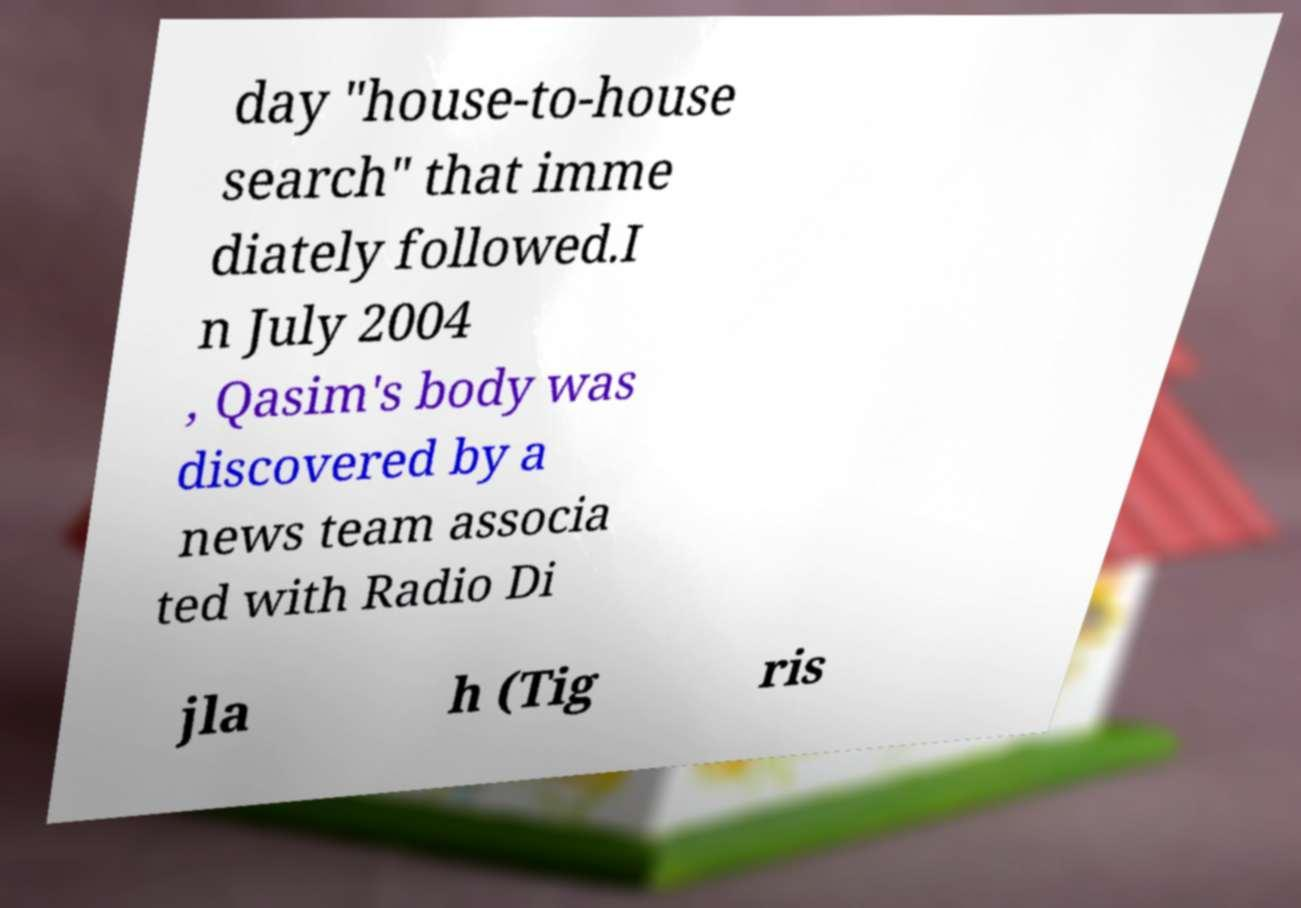Could you assist in decoding the text presented in this image and type it out clearly? day "house-to-house search" that imme diately followed.I n July 2004 , Qasim's body was discovered by a news team associa ted with Radio Di jla h (Tig ris 